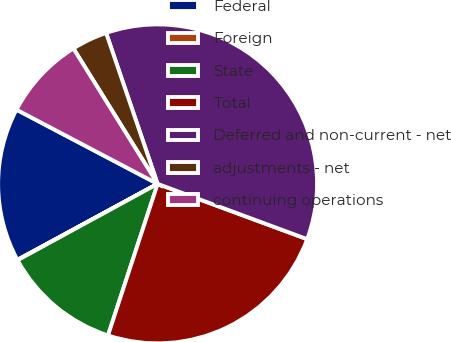<chart> <loc_0><loc_0><loc_500><loc_500><pie_chart><fcel>Federal<fcel>Foreign<fcel>State<fcel>Total<fcel>Deferred and non-current - net<fcel>adjustments - net<fcel>continuing operations<nl><fcel>15.61%<fcel>0.04%<fcel>12.02%<fcel>24.4%<fcel>35.87%<fcel>3.62%<fcel>8.44%<nl></chart> 